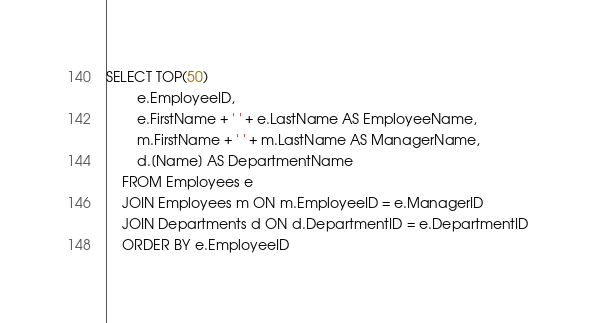Convert code to text. <code><loc_0><loc_0><loc_500><loc_500><_SQL_>SELECT TOP(50)
		e.EmployeeID, 
		e.FirstName + ' ' + e.LastName AS EmployeeName, 
		m.FirstName + ' ' + m.LastName AS ManagerName,
		d.[Name] AS DepartmentName
	FROM Employees e
	JOIN Employees m ON m.EmployeeID = e.ManagerID
	JOIN Departments d ON d.DepartmentID = e.DepartmentID
	ORDER BY e.EmployeeID
</code> 